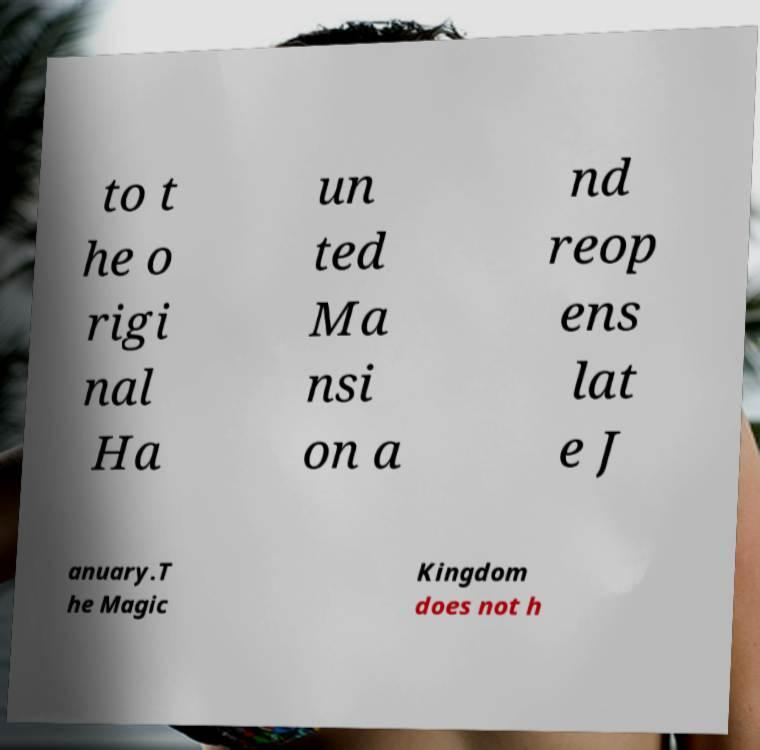Could you assist in decoding the text presented in this image and type it out clearly? to t he o rigi nal Ha un ted Ma nsi on a nd reop ens lat e J anuary.T he Magic Kingdom does not h 